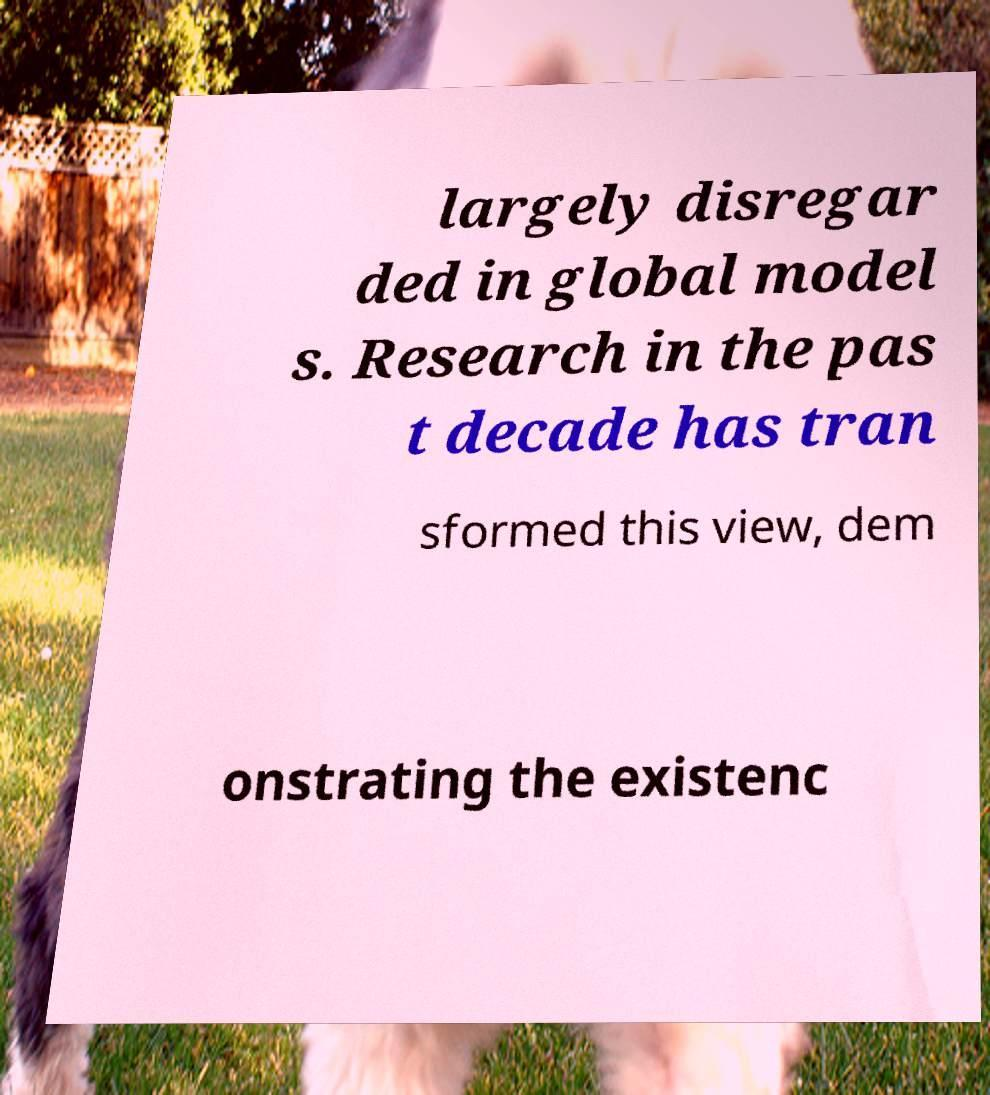There's text embedded in this image that I need extracted. Can you transcribe it verbatim? largely disregar ded in global model s. Research in the pas t decade has tran sformed this view, dem onstrating the existenc 